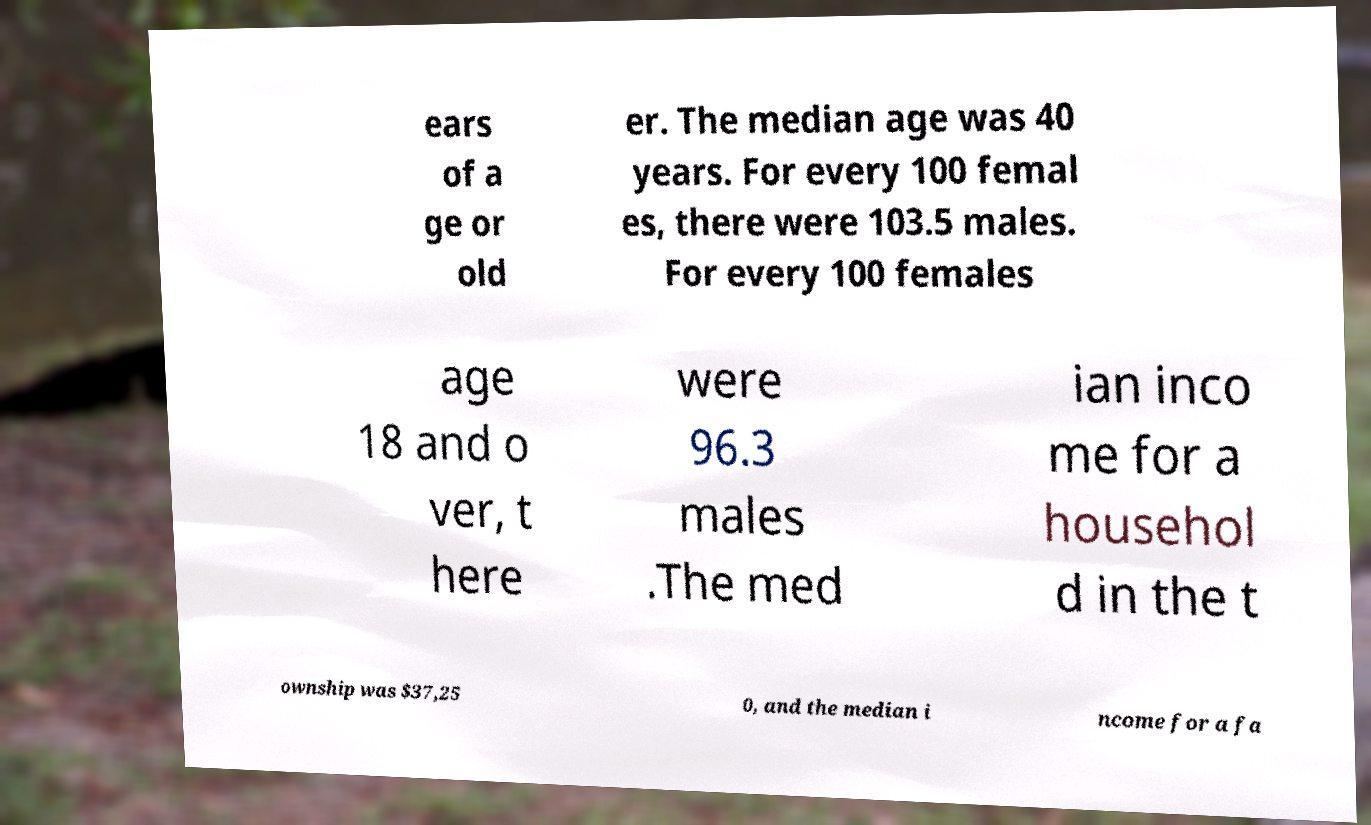Can you read and provide the text displayed in the image?This photo seems to have some interesting text. Can you extract and type it out for me? ears of a ge or old er. The median age was 40 years. For every 100 femal es, there were 103.5 males. For every 100 females age 18 and o ver, t here were 96.3 males .The med ian inco me for a househol d in the t ownship was $37,25 0, and the median i ncome for a fa 